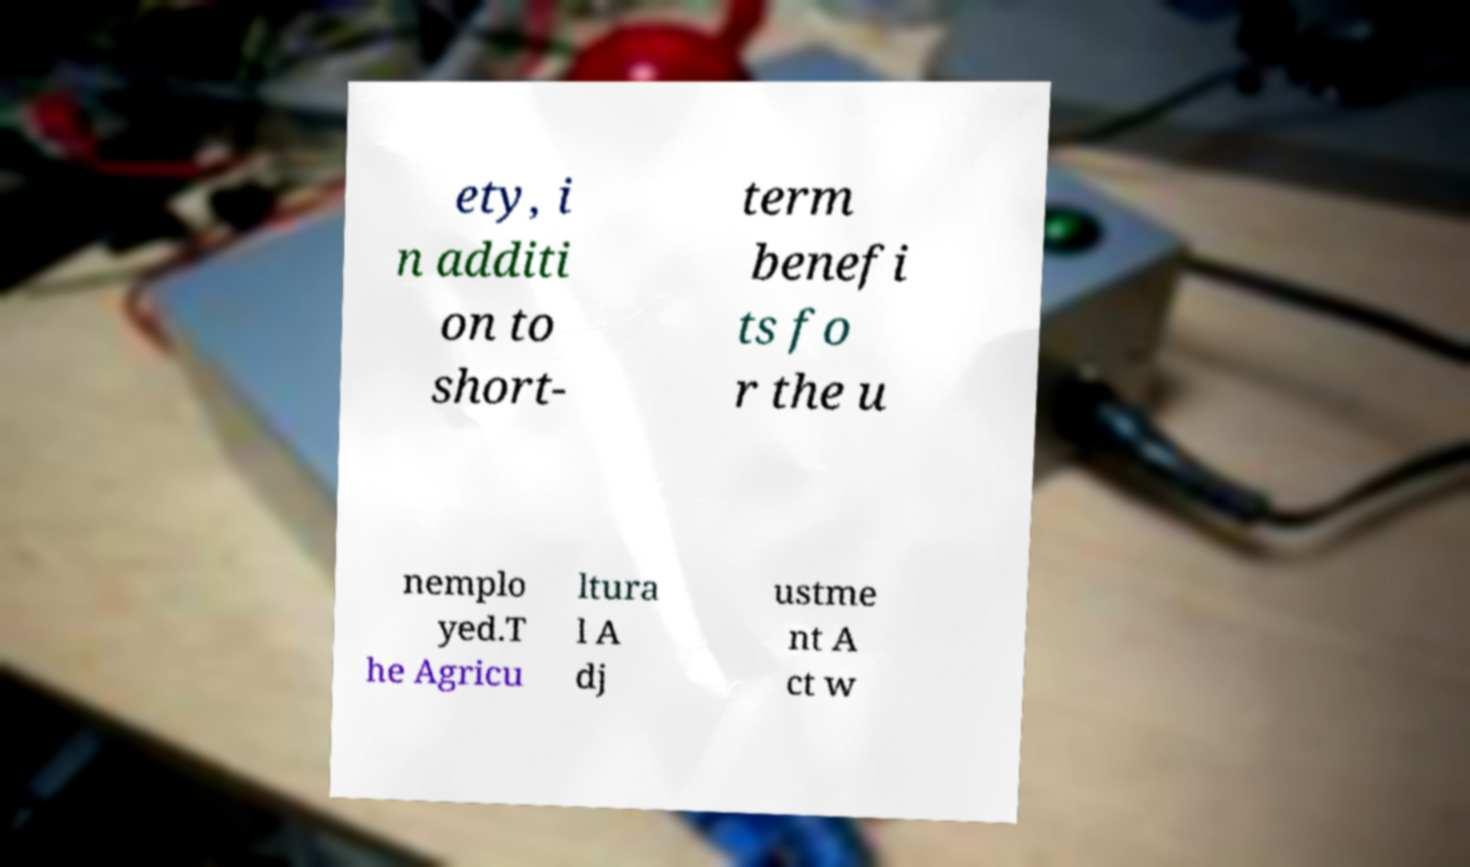Can you accurately transcribe the text from the provided image for me? ety, i n additi on to short- term benefi ts fo r the u nemplo yed.T he Agricu ltura l A dj ustme nt A ct w 